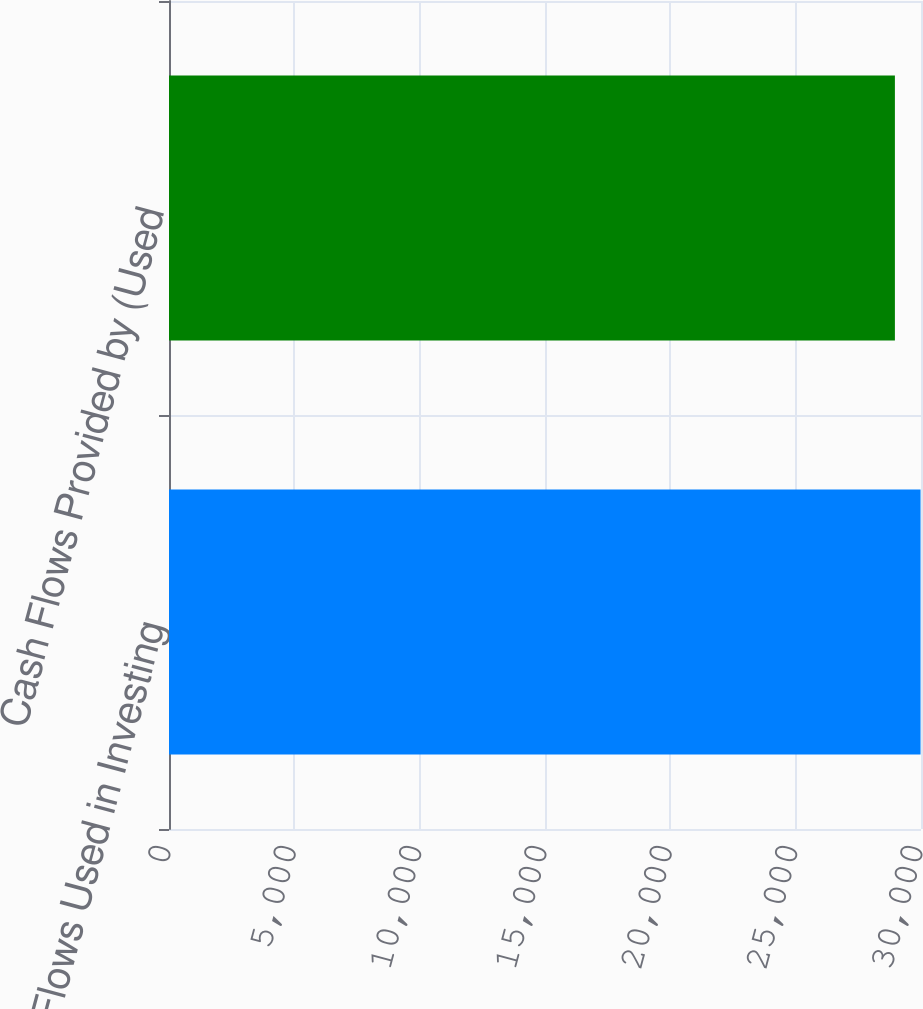Convert chart. <chart><loc_0><loc_0><loc_500><loc_500><bar_chart><fcel>Cash Flows Used in Investing<fcel>Cash Flows Provided by (Used<nl><fcel>29982<fcel>28959<nl></chart> 